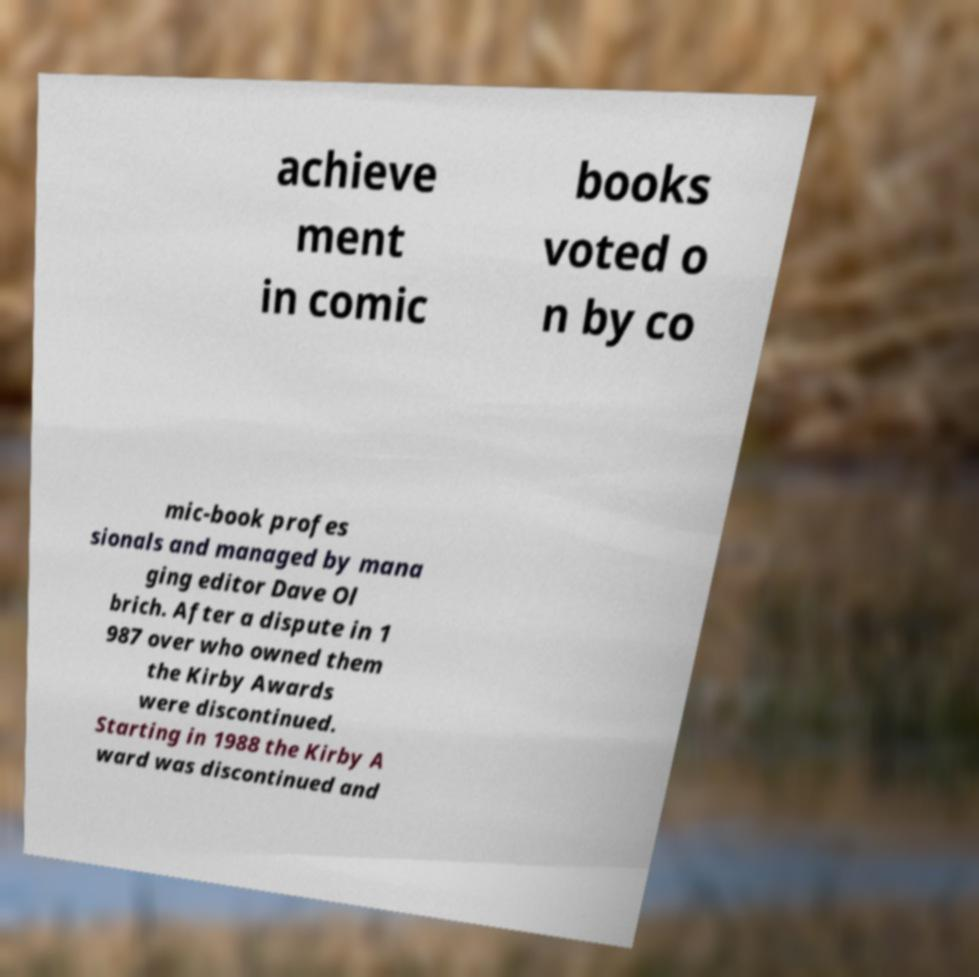Can you accurately transcribe the text from the provided image for me? achieve ment in comic books voted o n by co mic-book profes sionals and managed by mana ging editor Dave Ol brich. After a dispute in 1 987 over who owned them the Kirby Awards were discontinued. Starting in 1988 the Kirby A ward was discontinued and 